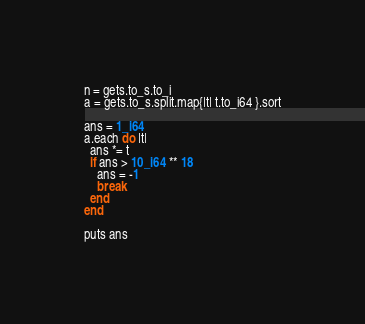Convert code to text. <code><loc_0><loc_0><loc_500><loc_500><_Crystal_>n = gets.to_s.to_i
a = gets.to_s.split.map{|t| t.to_i64 }.sort

ans = 1_i64
a.each do |t|
  ans *= t
  if ans > 10_i64 ** 18
    ans = -1
    break
  end
end

puts ans</code> 